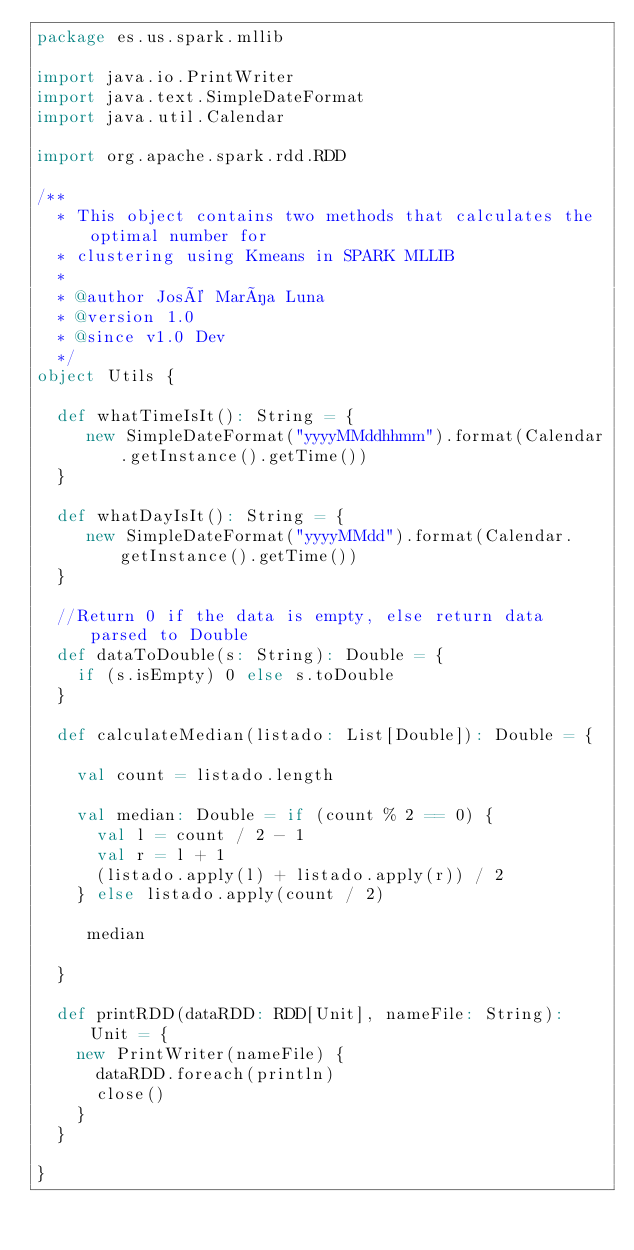<code> <loc_0><loc_0><loc_500><loc_500><_Scala_>package es.us.spark.mllib

import java.io.PrintWriter
import java.text.SimpleDateFormat
import java.util.Calendar

import org.apache.spark.rdd.RDD

/**
  * This object contains two methods that calculates the optimal number for
  * clustering using Kmeans in SPARK MLLIB
  *
  * @author José María Luna
  * @version 1.0
  * @since v1.0 Dev
  */
object Utils {

  def whatTimeIsIt(): String = {
     new SimpleDateFormat("yyyyMMddhhmm").format(Calendar.getInstance().getTime())
  }

  def whatDayIsIt(): String = {
     new SimpleDateFormat("yyyyMMdd").format(Calendar.getInstance().getTime())
  }

  //Return 0 if the data is empty, else return data parsed to Double
  def dataToDouble(s: String): Double = {
    if (s.isEmpty) 0 else s.toDouble
  }

  def calculateMedian(listado: List[Double]): Double = {

    val count = listado.length

    val median: Double = if (count % 2 == 0) {
      val l = count / 2 - 1
      val r = l + 1
      (listado.apply(l) + listado.apply(r)) / 2
    } else listado.apply(count / 2)

     median

  }

  def printRDD(dataRDD: RDD[Unit], nameFile: String): Unit = {
    new PrintWriter(nameFile) {
      dataRDD.foreach(println)
      close()
    }
  }

}
</code> 